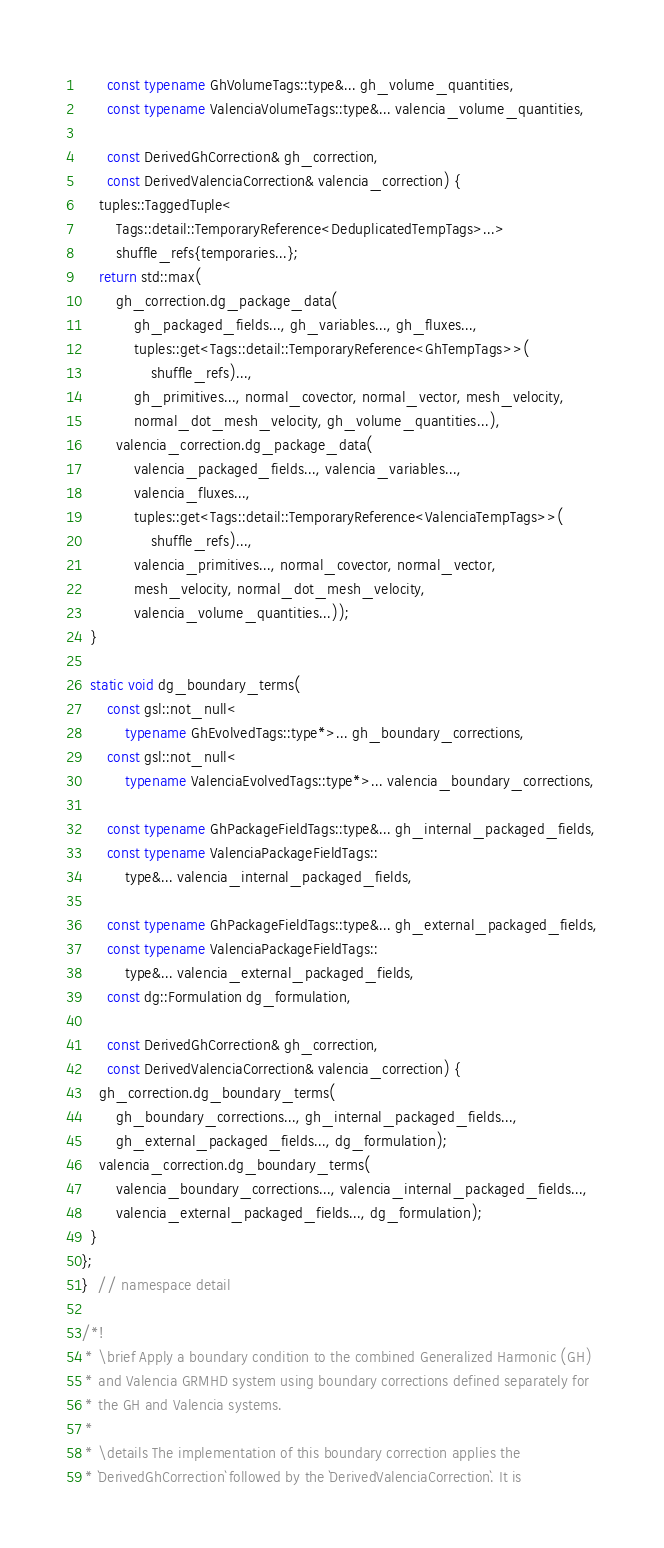<code> <loc_0><loc_0><loc_500><loc_500><_C++_>      const typename GhVolumeTags::type&... gh_volume_quantities,
      const typename ValenciaVolumeTags::type&... valencia_volume_quantities,

      const DerivedGhCorrection& gh_correction,
      const DerivedValenciaCorrection& valencia_correction) {
    tuples::TaggedTuple<
        Tags::detail::TemporaryReference<DeduplicatedTempTags>...>
        shuffle_refs{temporaries...};
    return std::max(
        gh_correction.dg_package_data(
            gh_packaged_fields..., gh_variables..., gh_fluxes...,
            tuples::get<Tags::detail::TemporaryReference<GhTempTags>>(
                shuffle_refs)...,
            gh_primitives..., normal_covector, normal_vector, mesh_velocity,
            normal_dot_mesh_velocity, gh_volume_quantities...),
        valencia_correction.dg_package_data(
            valencia_packaged_fields..., valencia_variables...,
            valencia_fluxes...,
            tuples::get<Tags::detail::TemporaryReference<ValenciaTempTags>>(
                shuffle_refs)...,
            valencia_primitives..., normal_covector, normal_vector,
            mesh_velocity, normal_dot_mesh_velocity,
            valencia_volume_quantities...));
  }

  static void dg_boundary_terms(
      const gsl::not_null<
          typename GhEvolvedTags::type*>... gh_boundary_corrections,
      const gsl::not_null<
          typename ValenciaEvolvedTags::type*>... valencia_boundary_corrections,

      const typename GhPackageFieldTags::type&... gh_internal_packaged_fields,
      const typename ValenciaPackageFieldTags::
          type&... valencia_internal_packaged_fields,

      const typename GhPackageFieldTags::type&... gh_external_packaged_fields,
      const typename ValenciaPackageFieldTags::
          type&... valencia_external_packaged_fields,
      const dg::Formulation dg_formulation,

      const DerivedGhCorrection& gh_correction,
      const DerivedValenciaCorrection& valencia_correction) {
    gh_correction.dg_boundary_terms(
        gh_boundary_corrections..., gh_internal_packaged_fields...,
        gh_external_packaged_fields..., dg_formulation);
    valencia_correction.dg_boundary_terms(
        valencia_boundary_corrections..., valencia_internal_packaged_fields...,
        valencia_external_packaged_fields..., dg_formulation);
  }
};
}  // namespace detail

/*!
 * \brief Apply a boundary condition to the combined Generalized Harmonic (GH)
 * and Valencia GRMHD system using boundary corrections defined separately for
 * the GH and Valencia systems.
 *
 * \details The implementation of this boundary correction applies the
 * `DerivedGhCorrection` followed by the `DerivedValenciaCorrection`. It is</code> 